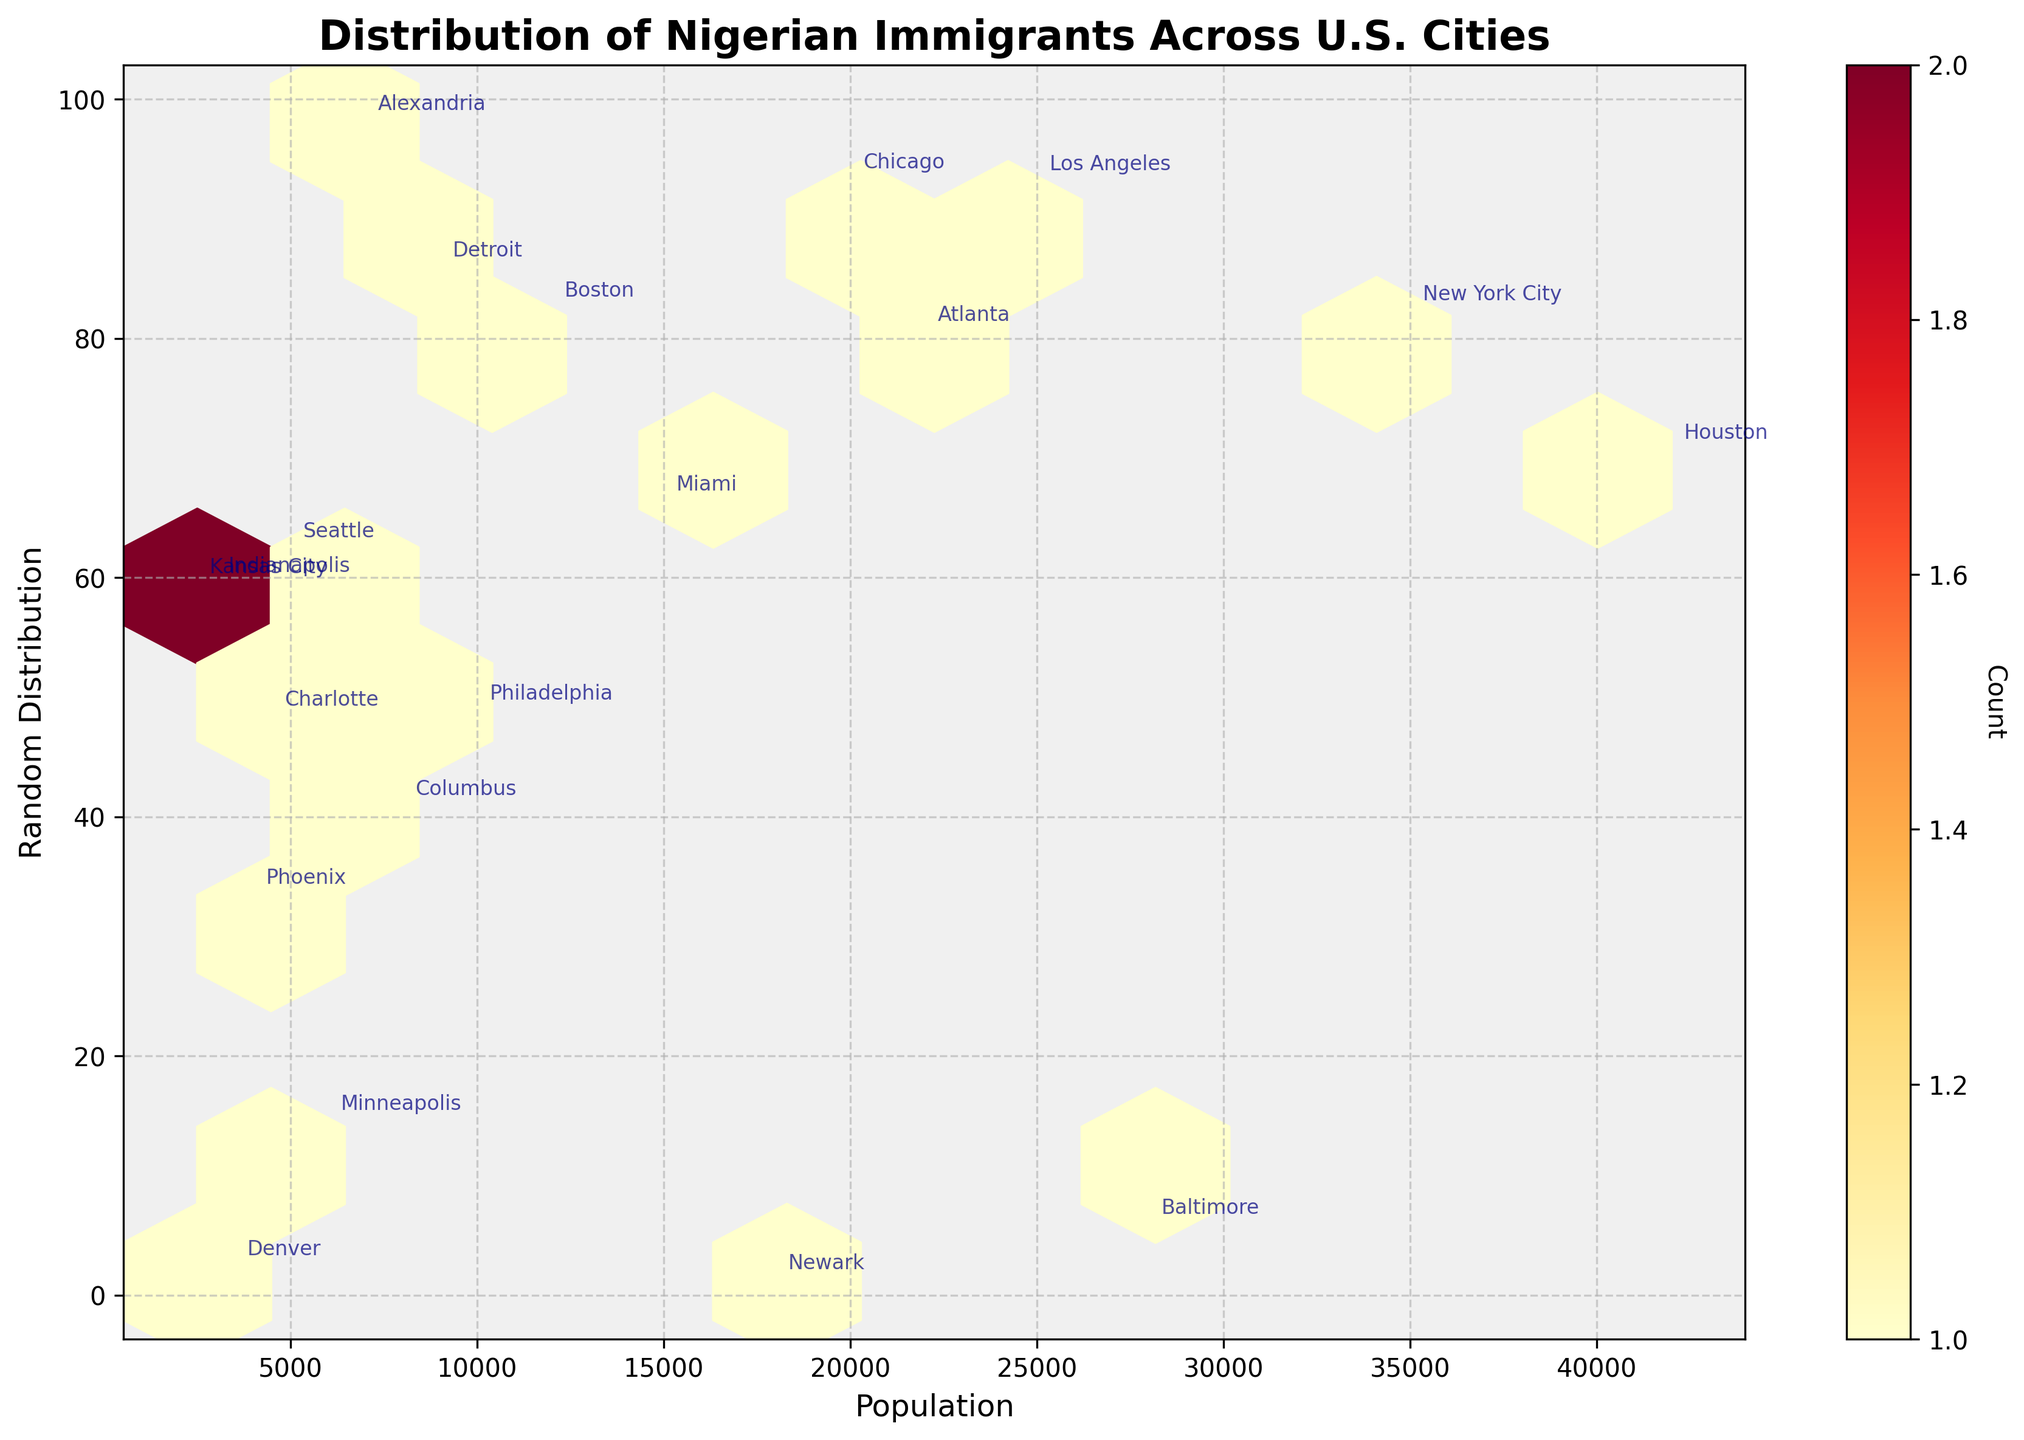What is the title of the plot? The title is usually found at the top of the chart. In this case, it provides an overview of what the chart is about.
Answer: Distribution of Nigerian Immigrants Across U.S. Cities What are the x and y labels of the plot? X and y labels provide context to the data on the corresponding axes. They are located along the axes.
Answer: Population (x), Random Distribution (y) How many hexagons are there in the plot approximately? To determine this, count the number of hexagons displayed on the plot. Each hexagon represents a specific range of data.
Answer: Approximately 15 Which city has the highest population of Nigerian immigrants according to the plot? The city with the highest population will be annotated near the largest value on the x-axis.
Answer: Houston What color represents the highest density of data points in the hexbin plot? The colorbar indicates the density levels, where the highest density will typically be indicated by the darkest or most intense color.
Answer: Red Which two cities have the smallest populations of Nigerian immigrants? Compare the population values next to the city annotations to identify the two lowest ones.
Answer: Kansas City and Indianapolis On average, do cities with higher populations show more density in the hexbin plot? By examining the color intensity distributed along higher population values on the x-axis, determine if there are more dark-colored hexagons.
Answer: Yes What is the approximate population range covered by the plot? Look at the minimum and maximum points on the x-axis to determine the range.
Answer: 2,500 to 42,000 What city is marked at around 35,000 population? Find the annotation near the x-axis value of 35,000 to determine the corresponding city.
Answer: New York City Are there more cities with populations above or below 20,000? Count the number of annotations for cities with populations above and below 20,000.
Answer: Below 20,000 Which hexbin plot feature indicates the concentration of data points more accurately than a scatter plot? Hexbin plots use color intensity to show data concentration, while scatter plots show individual data points. The color intensity in the hexbin plot represents the count of points within each bin, making it easier to identify areas with higher data concentrations.
Answer: Color intensity 